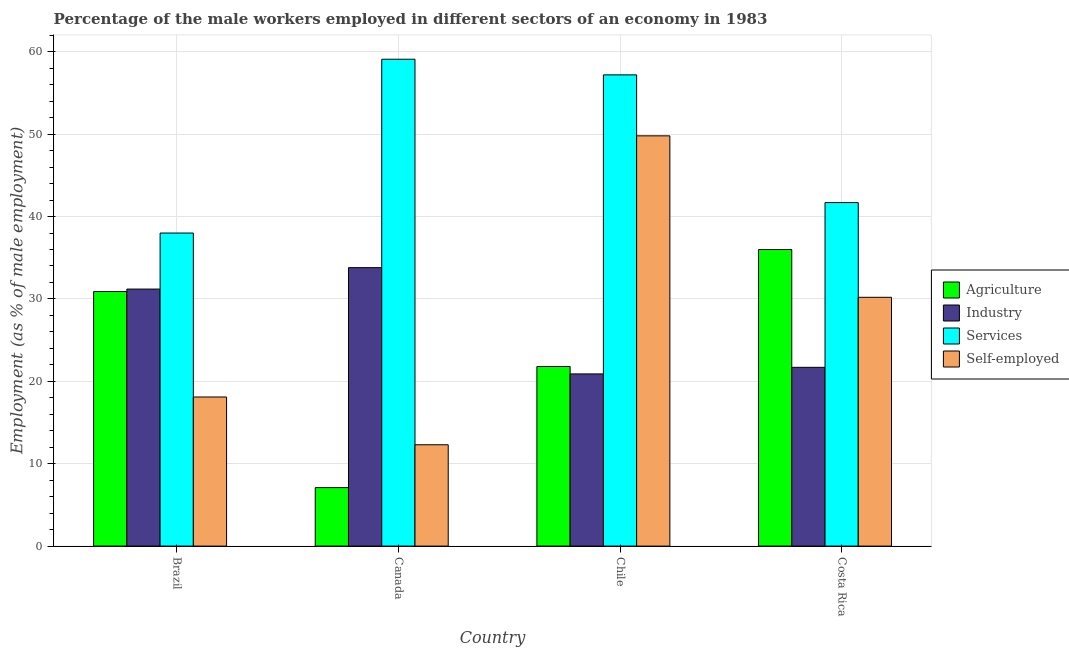How many different coloured bars are there?
Your answer should be compact. 4. Are the number of bars on each tick of the X-axis equal?
Provide a succinct answer. Yes. How many bars are there on the 3rd tick from the left?
Make the answer very short. 4. How many bars are there on the 3rd tick from the right?
Offer a terse response. 4. What is the percentage of self employed male workers in Brazil?
Your answer should be compact. 18.1. Across all countries, what is the maximum percentage of male workers in industry?
Ensure brevity in your answer.  33.8. Across all countries, what is the minimum percentage of male workers in services?
Keep it short and to the point. 38. In which country was the percentage of male workers in industry maximum?
Your response must be concise. Canada. What is the total percentage of self employed male workers in the graph?
Offer a terse response. 110.4. What is the difference between the percentage of male workers in agriculture in Brazil and that in Canada?
Make the answer very short. 23.8. What is the difference between the percentage of male workers in industry in Chile and the percentage of male workers in services in Costa Rica?
Ensure brevity in your answer.  -20.8. What is the average percentage of male workers in industry per country?
Your response must be concise. 26.9. What is the difference between the percentage of male workers in services and percentage of male workers in industry in Canada?
Your answer should be very brief. 25.3. What is the ratio of the percentage of male workers in agriculture in Chile to that in Costa Rica?
Make the answer very short. 0.61. Is the percentage of male workers in services in Canada less than that in Chile?
Your answer should be compact. No. Is the difference between the percentage of male workers in agriculture in Brazil and Canada greater than the difference between the percentage of self employed male workers in Brazil and Canada?
Ensure brevity in your answer.  Yes. What is the difference between the highest and the second highest percentage of self employed male workers?
Give a very brief answer. 19.6. What is the difference between the highest and the lowest percentage of male workers in industry?
Offer a very short reply. 12.9. In how many countries, is the percentage of male workers in agriculture greater than the average percentage of male workers in agriculture taken over all countries?
Offer a terse response. 2. Is the sum of the percentage of male workers in services in Canada and Costa Rica greater than the maximum percentage of male workers in agriculture across all countries?
Your answer should be very brief. Yes. What does the 2nd bar from the left in Canada represents?
Your answer should be compact. Industry. What does the 2nd bar from the right in Chile represents?
Your response must be concise. Services. Is it the case that in every country, the sum of the percentage of male workers in agriculture and percentage of male workers in industry is greater than the percentage of male workers in services?
Give a very brief answer. No. Does the graph contain any zero values?
Offer a terse response. No. Where does the legend appear in the graph?
Offer a terse response. Center right. What is the title of the graph?
Offer a very short reply. Percentage of the male workers employed in different sectors of an economy in 1983. Does "WHO" appear as one of the legend labels in the graph?
Your answer should be compact. No. What is the label or title of the Y-axis?
Offer a terse response. Employment (as % of male employment). What is the Employment (as % of male employment) in Agriculture in Brazil?
Offer a very short reply. 30.9. What is the Employment (as % of male employment) of Industry in Brazil?
Offer a very short reply. 31.2. What is the Employment (as % of male employment) of Services in Brazil?
Give a very brief answer. 38. What is the Employment (as % of male employment) in Self-employed in Brazil?
Provide a short and direct response. 18.1. What is the Employment (as % of male employment) in Agriculture in Canada?
Offer a very short reply. 7.1. What is the Employment (as % of male employment) in Industry in Canada?
Your response must be concise. 33.8. What is the Employment (as % of male employment) in Services in Canada?
Provide a short and direct response. 59.1. What is the Employment (as % of male employment) in Self-employed in Canada?
Make the answer very short. 12.3. What is the Employment (as % of male employment) of Agriculture in Chile?
Your response must be concise. 21.8. What is the Employment (as % of male employment) in Industry in Chile?
Ensure brevity in your answer.  20.9. What is the Employment (as % of male employment) in Services in Chile?
Offer a terse response. 57.2. What is the Employment (as % of male employment) of Self-employed in Chile?
Give a very brief answer. 49.8. What is the Employment (as % of male employment) of Agriculture in Costa Rica?
Keep it short and to the point. 36. What is the Employment (as % of male employment) of Industry in Costa Rica?
Provide a succinct answer. 21.7. What is the Employment (as % of male employment) of Services in Costa Rica?
Provide a short and direct response. 41.7. What is the Employment (as % of male employment) in Self-employed in Costa Rica?
Offer a terse response. 30.2. Across all countries, what is the maximum Employment (as % of male employment) of Industry?
Keep it short and to the point. 33.8. Across all countries, what is the maximum Employment (as % of male employment) of Services?
Your answer should be compact. 59.1. Across all countries, what is the maximum Employment (as % of male employment) of Self-employed?
Offer a terse response. 49.8. Across all countries, what is the minimum Employment (as % of male employment) of Agriculture?
Make the answer very short. 7.1. Across all countries, what is the minimum Employment (as % of male employment) in Industry?
Provide a short and direct response. 20.9. Across all countries, what is the minimum Employment (as % of male employment) of Self-employed?
Offer a terse response. 12.3. What is the total Employment (as % of male employment) of Agriculture in the graph?
Offer a very short reply. 95.8. What is the total Employment (as % of male employment) in Industry in the graph?
Offer a terse response. 107.6. What is the total Employment (as % of male employment) of Services in the graph?
Your answer should be very brief. 196. What is the total Employment (as % of male employment) of Self-employed in the graph?
Provide a short and direct response. 110.4. What is the difference between the Employment (as % of male employment) of Agriculture in Brazil and that in Canada?
Offer a very short reply. 23.8. What is the difference between the Employment (as % of male employment) of Industry in Brazil and that in Canada?
Keep it short and to the point. -2.6. What is the difference between the Employment (as % of male employment) in Services in Brazil and that in Canada?
Your answer should be compact. -21.1. What is the difference between the Employment (as % of male employment) of Agriculture in Brazil and that in Chile?
Keep it short and to the point. 9.1. What is the difference between the Employment (as % of male employment) of Services in Brazil and that in Chile?
Ensure brevity in your answer.  -19.2. What is the difference between the Employment (as % of male employment) in Self-employed in Brazil and that in Chile?
Provide a short and direct response. -31.7. What is the difference between the Employment (as % of male employment) of Agriculture in Brazil and that in Costa Rica?
Make the answer very short. -5.1. What is the difference between the Employment (as % of male employment) of Industry in Brazil and that in Costa Rica?
Your answer should be compact. 9.5. What is the difference between the Employment (as % of male employment) in Services in Brazil and that in Costa Rica?
Keep it short and to the point. -3.7. What is the difference between the Employment (as % of male employment) of Agriculture in Canada and that in Chile?
Offer a terse response. -14.7. What is the difference between the Employment (as % of male employment) of Industry in Canada and that in Chile?
Keep it short and to the point. 12.9. What is the difference between the Employment (as % of male employment) of Services in Canada and that in Chile?
Keep it short and to the point. 1.9. What is the difference between the Employment (as % of male employment) in Self-employed in Canada and that in Chile?
Give a very brief answer. -37.5. What is the difference between the Employment (as % of male employment) of Agriculture in Canada and that in Costa Rica?
Provide a succinct answer. -28.9. What is the difference between the Employment (as % of male employment) in Self-employed in Canada and that in Costa Rica?
Offer a terse response. -17.9. What is the difference between the Employment (as % of male employment) of Services in Chile and that in Costa Rica?
Your answer should be compact. 15.5. What is the difference between the Employment (as % of male employment) in Self-employed in Chile and that in Costa Rica?
Your answer should be very brief. 19.6. What is the difference between the Employment (as % of male employment) in Agriculture in Brazil and the Employment (as % of male employment) in Industry in Canada?
Offer a very short reply. -2.9. What is the difference between the Employment (as % of male employment) of Agriculture in Brazil and the Employment (as % of male employment) of Services in Canada?
Your response must be concise. -28.2. What is the difference between the Employment (as % of male employment) in Industry in Brazil and the Employment (as % of male employment) in Services in Canada?
Your response must be concise. -27.9. What is the difference between the Employment (as % of male employment) of Industry in Brazil and the Employment (as % of male employment) of Self-employed in Canada?
Your answer should be very brief. 18.9. What is the difference between the Employment (as % of male employment) in Services in Brazil and the Employment (as % of male employment) in Self-employed in Canada?
Your answer should be compact. 25.7. What is the difference between the Employment (as % of male employment) of Agriculture in Brazil and the Employment (as % of male employment) of Industry in Chile?
Provide a succinct answer. 10. What is the difference between the Employment (as % of male employment) in Agriculture in Brazil and the Employment (as % of male employment) in Services in Chile?
Give a very brief answer. -26.3. What is the difference between the Employment (as % of male employment) in Agriculture in Brazil and the Employment (as % of male employment) in Self-employed in Chile?
Ensure brevity in your answer.  -18.9. What is the difference between the Employment (as % of male employment) in Industry in Brazil and the Employment (as % of male employment) in Services in Chile?
Offer a terse response. -26. What is the difference between the Employment (as % of male employment) of Industry in Brazil and the Employment (as % of male employment) of Self-employed in Chile?
Your answer should be very brief. -18.6. What is the difference between the Employment (as % of male employment) of Industry in Brazil and the Employment (as % of male employment) of Services in Costa Rica?
Your answer should be compact. -10.5. What is the difference between the Employment (as % of male employment) of Agriculture in Canada and the Employment (as % of male employment) of Services in Chile?
Your answer should be very brief. -50.1. What is the difference between the Employment (as % of male employment) in Agriculture in Canada and the Employment (as % of male employment) in Self-employed in Chile?
Offer a terse response. -42.7. What is the difference between the Employment (as % of male employment) in Industry in Canada and the Employment (as % of male employment) in Services in Chile?
Make the answer very short. -23.4. What is the difference between the Employment (as % of male employment) in Industry in Canada and the Employment (as % of male employment) in Self-employed in Chile?
Make the answer very short. -16. What is the difference between the Employment (as % of male employment) in Services in Canada and the Employment (as % of male employment) in Self-employed in Chile?
Offer a very short reply. 9.3. What is the difference between the Employment (as % of male employment) in Agriculture in Canada and the Employment (as % of male employment) in Industry in Costa Rica?
Provide a succinct answer. -14.6. What is the difference between the Employment (as % of male employment) of Agriculture in Canada and the Employment (as % of male employment) of Services in Costa Rica?
Keep it short and to the point. -34.6. What is the difference between the Employment (as % of male employment) in Agriculture in Canada and the Employment (as % of male employment) in Self-employed in Costa Rica?
Your answer should be compact. -23.1. What is the difference between the Employment (as % of male employment) of Industry in Canada and the Employment (as % of male employment) of Self-employed in Costa Rica?
Offer a very short reply. 3.6. What is the difference between the Employment (as % of male employment) in Services in Canada and the Employment (as % of male employment) in Self-employed in Costa Rica?
Give a very brief answer. 28.9. What is the difference between the Employment (as % of male employment) of Agriculture in Chile and the Employment (as % of male employment) of Services in Costa Rica?
Ensure brevity in your answer.  -19.9. What is the difference between the Employment (as % of male employment) in Industry in Chile and the Employment (as % of male employment) in Services in Costa Rica?
Offer a terse response. -20.8. What is the difference between the Employment (as % of male employment) of Industry in Chile and the Employment (as % of male employment) of Self-employed in Costa Rica?
Your answer should be very brief. -9.3. What is the difference between the Employment (as % of male employment) of Services in Chile and the Employment (as % of male employment) of Self-employed in Costa Rica?
Offer a very short reply. 27. What is the average Employment (as % of male employment) in Agriculture per country?
Offer a terse response. 23.95. What is the average Employment (as % of male employment) in Industry per country?
Your answer should be very brief. 26.9. What is the average Employment (as % of male employment) of Services per country?
Give a very brief answer. 49. What is the average Employment (as % of male employment) in Self-employed per country?
Offer a very short reply. 27.6. What is the difference between the Employment (as % of male employment) in Agriculture and Employment (as % of male employment) in Services in Brazil?
Offer a very short reply. -7.1. What is the difference between the Employment (as % of male employment) in Agriculture and Employment (as % of male employment) in Self-employed in Brazil?
Your answer should be compact. 12.8. What is the difference between the Employment (as % of male employment) of Industry and Employment (as % of male employment) of Services in Brazil?
Your answer should be compact. -6.8. What is the difference between the Employment (as % of male employment) of Industry and Employment (as % of male employment) of Self-employed in Brazil?
Give a very brief answer. 13.1. What is the difference between the Employment (as % of male employment) of Agriculture and Employment (as % of male employment) of Industry in Canada?
Offer a very short reply. -26.7. What is the difference between the Employment (as % of male employment) in Agriculture and Employment (as % of male employment) in Services in Canada?
Offer a very short reply. -52. What is the difference between the Employment (as % of male employment) in Agriculture and Employment (as % of male employment) in Self-employed in Canada?
Give a very brief answer. -5.2. What is the difference between the Employment (as % of male employment) in Industry and Employment (as % of male employment) in Services in Canada?
Offer a very short reply. -25.3. What is the difference between the Employment (as % of male employment) of Services and Employment (as % of male employment) of Self-employed in Canada?
Offer a terse response. 46.8. What is the difference between the Employment (as % of male employment) of Agriculture and Employment (as % of male employment) of Industry in Chile?
Provide a short and direct response. 0.9. What is the difference between the Employment (as % of male employment) of Agriculture and Employment (as % of male employment) of Services in Chile?
Keep it short and to the point. -35.4. What is the difference between the Employment (as % of male employment) of Industry and Employment (as % of male employment) of Services in Chile?
Your answer should be compact. -36.3. What is the difference between the Employment (as % of male employment) in Industry and Employment (as % of male employment) in Self-employed in Chile?
Your response must be concise. -28.9. What is the difference between the Employment (as % of male employment) in Services and Employment (as % of male employment) in Self-employed in Chile?
Make the answer very short. 7.4. What is the difference between the Employment (as % of male employment) in Agriculture and Employment (as % of male employment) in Industry in Costa Rica?
Give a very brief answer. 14.3. What is the difference between the Employment (as % of male employment) in Agriculture and Employment (as % of male employment) in Services in Costa Rica?
Your answer should be very brief. -5.7. What is the difference between the Employment (as % of male employment) of Agriculture and Employment (as % of male employment) of Self-employed in Costa Rica?
Offer a very short reply. 5.8. What is the difference between the Employment (as % of male employment) in Industry and Employment (as % of male employment) in Services in Costa Rica?
Provide a short and direct response. -20. What is the difference between the Employment (as % of male employment) in Industry and Employment (as % of male employment) in Self-employed in Costa Rica?
Provide a short and direct response. -8.5. What is the difference between the Employment (as % of male employment) of Services and Employment (as % of male employment) of Self-employed in Costa Rica?
Provide a succinct answer. 11.5. What is the ratio of the Employment (as % of male employment) in Agriculture in Brazil to that in Canada?
Your answer should be compact. 4.35. What is the ratio of the Employment (as % of male employment) of Industry in Brazil to that in Canada?
Ensure brevity in your answer.  0.92. What is the ratio of the Employment (as % of male employment) in Services in Brazil to that in Canada?
Keep it short and to the point. 0.64. What is the ratio of the Employment (as % of male employment) in Self-employed in Brazil to that in Canada?
Offer a terse response. 1.47. What is the ratio of the Employment (as % of male employment) of Agriculture in Brazil to that in Chile?
Ensure brevity in your answer.  1.42. What is the ratio of the Employment (as % of male employment) in Industry in Brazil to that in Chile?
Provide a short and direct response. 1.49. What is the ratio of the Employment (as % of male employment) of Services in Brazil to that in Chile?
Keep it short and to the point. 0.66. What is the ratio of the Employment (as % of male employment) of Self-employed in Brazil to that in Chile?
Ensure brevity in your answer.  0.36. What is the ratio of the Employment (as % of male employment) of Agriculture in Brazil to that in Costa Rica?
Your answer should be compact. 0.86. What is the ratio of the Employment (as % of male employment) of Industry in Brazil to that in Costa Rica?
Your answer should be compact. 1.44. What is the ratio of the Employment (as % of male employment) in Services in Brazil to that in Costa Rica?
Your response must be concise. 0.91. What is the ratio of the Employment (as % of male employment) in Self-employed in Brazil to that in Costa Rica?
Provide a short and direct response. 0.6. What is the ratio of the Employment (as % of male employment) in Agriculture in Canada to that in Chile?
Your answer should be very brief. 0.33. What is the ratio of the Employment (as % of male employment) of Industry in Canada to that in Chile?
Your response must be concise. 1.62. What is the ratio of the Employment (as % of male employment) in Services in Canada to that in Chile?
Offer a very short reply. 1.03. What is the ratio of the Employment (as % of male employment) in Self-employed in Canada to that in Chile?
Provide a short and direct response. 0.25. What is the ratio of the Employment (as % of male employment) in Agriculture in Canada to that in Costa Rica?
Keep it short and to the point. 0.2. What is the ratio of the Employment (as % of male employment) in Industry in Canada to that in Costa Rica?
Offer a terse response. 1.56. What is the ratio of the Employment (as % of male employment) of Services in Canada to that in Costa Rica?
Keep it short and to the point. 1.42. What is the ratio of the Employment (as % of male employment) of Self-employed in Canada to that in Costa Rica?
Offer a very short reply. 0.41. What is the ratio of the Employment (as % of male employment) in Agriculture in Chile to that in Costa Rica?
Your response must be concise. 0.61. What is the ratio of the Employment (as % of male employment) of Industry in Chile to that in Costa Rica?
Ensure brevity in your answer.  0.96. What is the ratio of the Employment (as % of male employment) of Services in Chile to that in Costa Rica?
Your answer should be compact. 1.37. What is the ratio of the Employment (as % of male employment) in Self-employed in Chile to that in Costa Rica?
Your answer should be compact. 1.65. What is the difference between the highest and the second highest Employment (as % of male employment) in Agriculture?
Your answer should be compact. 5.1. What is the difference between the highest and the second highest Employment (as % of male employment) of Services?
Offer a very short reply. 1.9. What is the difference between the highest and the second highest Employment (as % of male employment) of Self-employed?
Provide a succinct answer. 19.6. What is the difference between the highest and the lowest Employment (as % of male employment) of Agriculture?
Provide a short and direct response. 28.9. What is the difference between the highest and the lowest Employment (as % of male employment) of Industry?
Provide a succinct answer. 12.9. What is the difference between the highest and the lowest Employment (as % of male employment) in Services?
Offer a very short reply. 21.1. What is the difference between the highest and the lowest Employment (as % of male employment) in Self-employed?
Your answer should be compact. 37.5. 